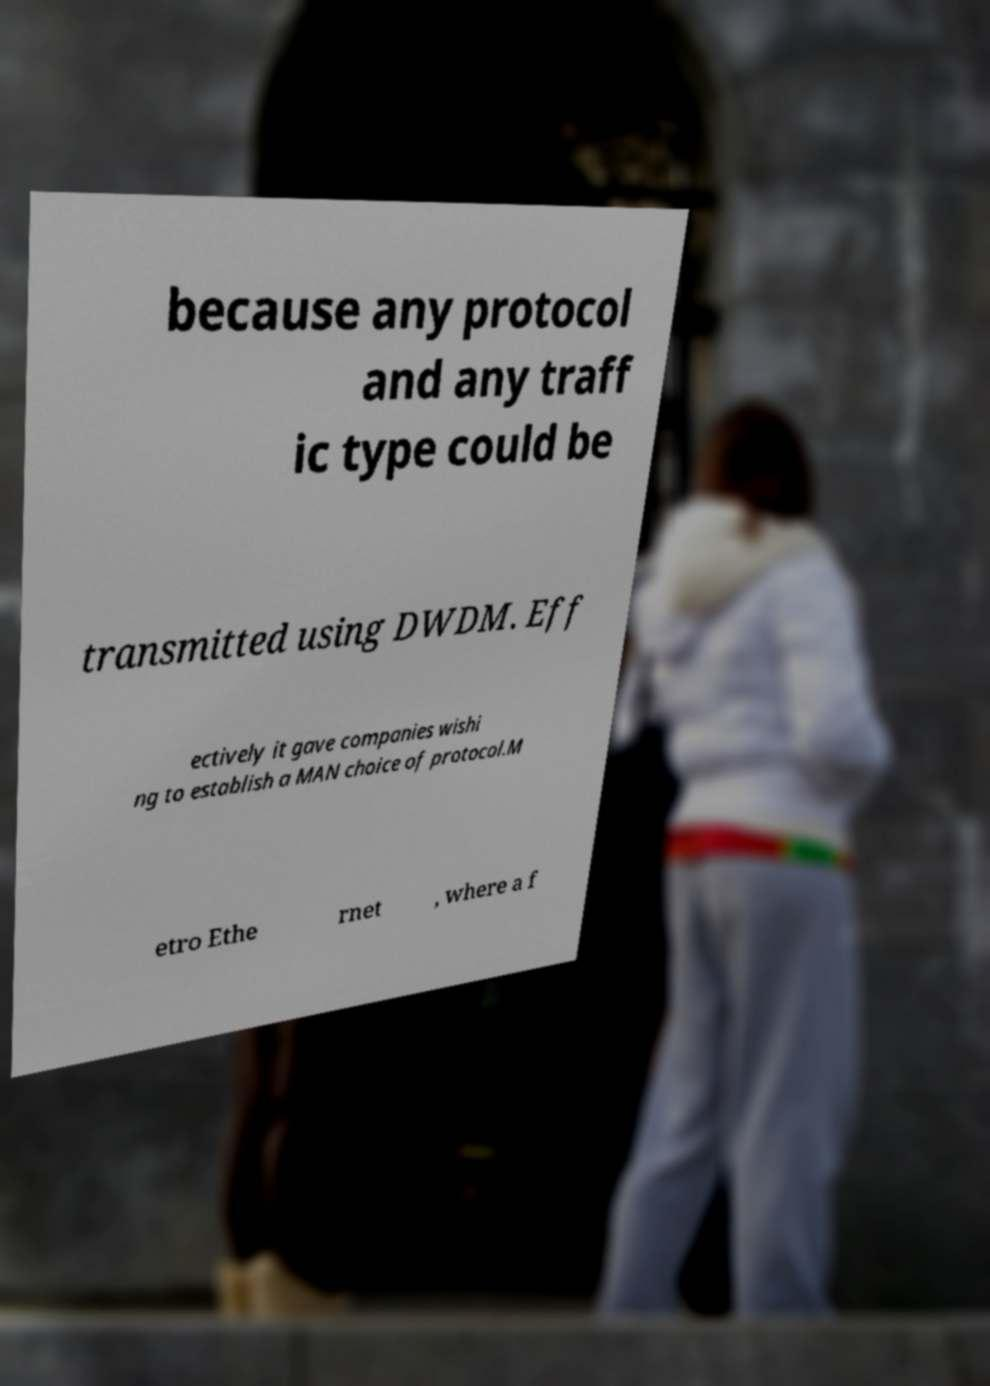What messages or text are displayed in this image? I need them in a readable, typed format. because any protocol and any traff ic type could be transmitted using DWDM. Eff ectively it gave companies wishi ng to establish a MAN choice of protocol.M etro Ethe rnet , where a f 